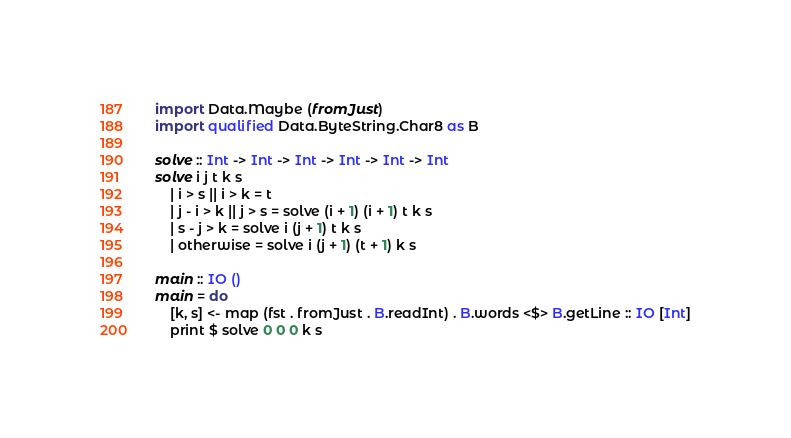<code> <loc_0><loc_0><loc_500><loc_500><_Haskell_>import Data.Maybe (fromJust)
import qualified Data.ByteString.Char8 as B

solve :: Int -> Int -> Int -> Int -> Int -> Int
solve i j t k s
    | i > s || i > k = t
    | j - i > k || j > s = solve (i + 1) (i + 1) t k s
    | s - j > k = solve i (j + 1) t k s
    | otherwise = solve i (j + 1) (t + 1) k s

main :: IO ()
main = do
    [k, s] <- map (fst . fromJust . B.readInt) . B.words <$> B.getLine :: IO [Int]
    print $ solve 0 0 0 k s
</code> 